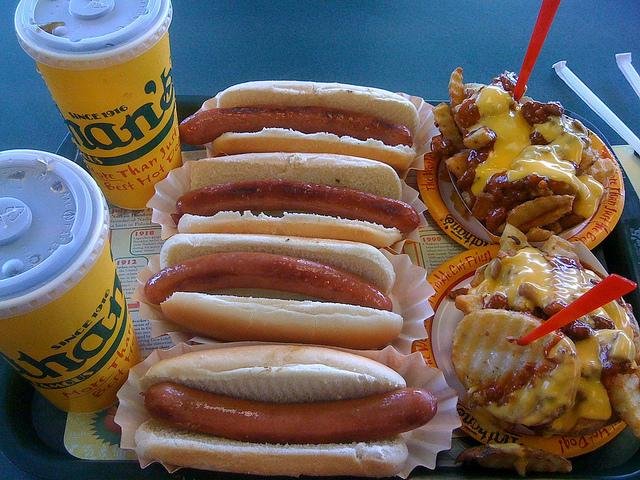What annual event is the company famous for? Please explain your reasoning. eating contest. The company listed on the cups is nathan's famous. the food items are hot dogs. 